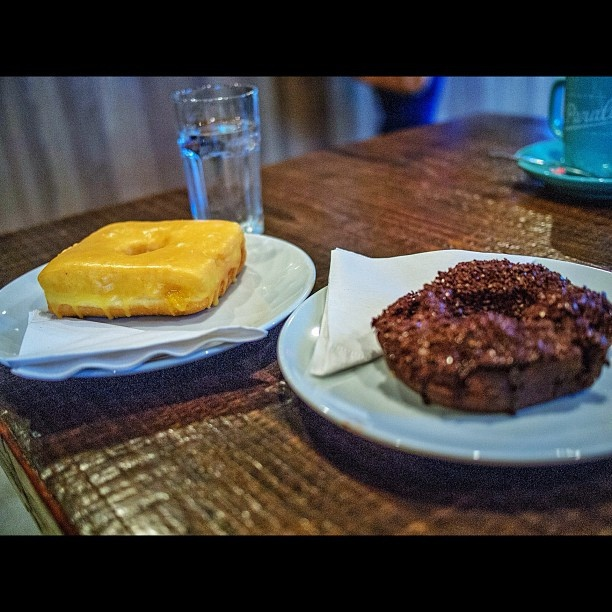Describe the objects in this image and their specific colors. I can see dining table in black, maroon, and gray tones, donut in black, maroon, and brown tones, cup in black, gray, and teal tones, donut in black, orange, olive, and tan tones, and spoon in black, teal, and gray tones in this image. 